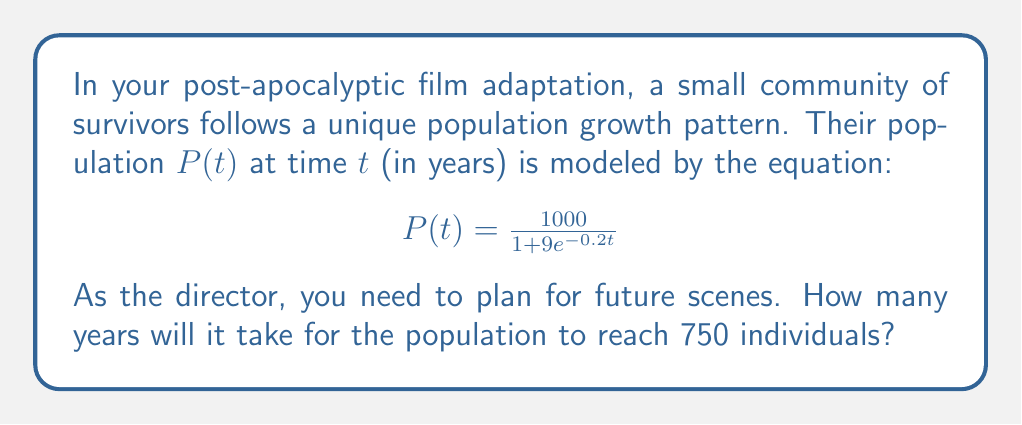Can you answer this question? To solve this problem, we need to follow these steps:

1) We want to find $t$ when $P(t) = 750$. So, we set up the equation:

   $$750 = \frac{1000}{1 + 9e^{-0.2t}}$$

2) Multiply both sides by $(1 + 9e^{-0.2t})$:

   $$750(1 + 9e^{-0.2t}) = 1000$$

3) Distribute on the left side:

   $$750 + 6750e^{-0.2t} = 1000$$

4) Subtract 750 from both sides:

   $$6750e^{-0.2t} = 250$$

5) Divide both sides by 6750:

   $$e^{-0.2t} = \frac{250}{6750} = \frac{1}{27}$$

6) Take the natural log of both sides:

   $$-0.2t = \ln(\frac{1}{27})$$

7) Divide both sides by -0.2:

   $$t = -\frac{\ln(\frac{1}{27})}{0.2}$$

8) Simplify:

   $$t = \frac{\ln(27)}{0.2} \approx 16.53$$

9) Since we're dealing with years, we round up to the nearest whole number.
Answer: It will take 17 years for the population to reach 750 individuals. 